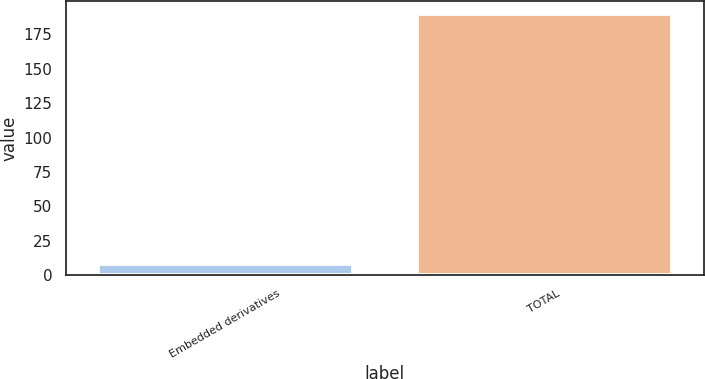<chart> <loc_0><loc_0><loc_500><loc_500><bar_chart><fcel>Embedded derivatives<fcel>TOTAL<nl><fcel>8<fcel>190<nl></chart> 